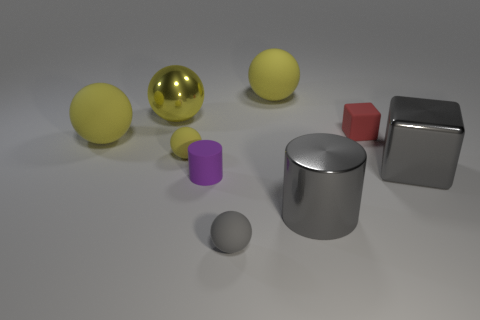Subtract all gray cylinders. How many yellow spheres are left? 4 Subtract all big metallic spheres. How many spheres are left? 4 Subtract all gray spheres. Subtract all green cylinders. How many spheres are left? 4 Subtract all spheres. How many objects are left? 4 Subtract 0 cyan cylinders. How many objects are left? 9 Subtract all tiny yellow spheres. Subtract all tiny gray matte things. How many objects are left? 7 Add 9 shiny blocks. How many shiny blocks are left? 10 Add 6 small red rubber cylinders. How many small red rubber cylinders exist? 6 